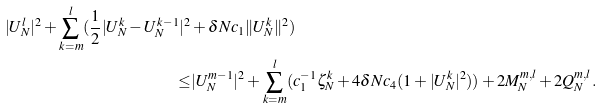<formula> <loc_0><loc_0><loc_500><loc_500>| U ^ { l } _ { N } | ^ { 2 } + \sum _ { k = m } ^ { l } ( \frac { 1 } { 2 } | U ^ { k } _ { N } - U ^ { k - 1 } _ { N } | ^ { 2 } & + \delta N c _ { 1 } \| U ^ { k } _ { N } \| ^ { 2 } ) \\ \leq & | U ^ { m - 1 } _ { N } | ^ { 2 } + \sum _ { k = m } ^ { l } ( c _ { 1 } ^ { - 1 } \zeta ^ { k } _ { N } + 4 \delta N c _ { 4 } ( 1 + | U ^ { k } _ { N } | ^ { 2 } ) ) + 2 M ^ { m , l } _ { N } + 2 Q ^ { m , l } _ { N } .</formula> 